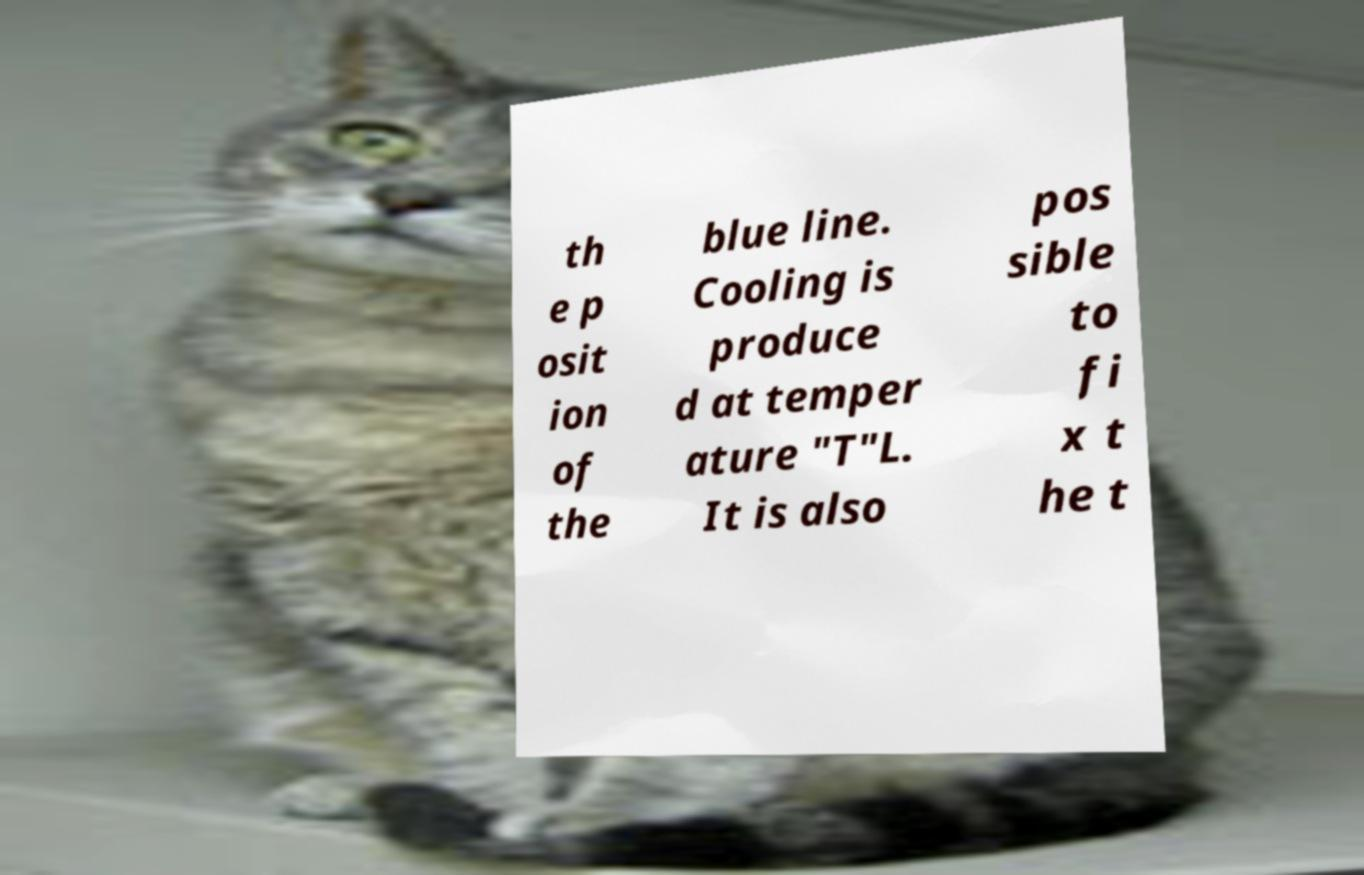What messages or text are displayed in this image? I need them in a readable, typed format. th e p osit ion of the blue line. Cooling is produce d at temper ature "T"L. It is also pos sible to fi x t he t 